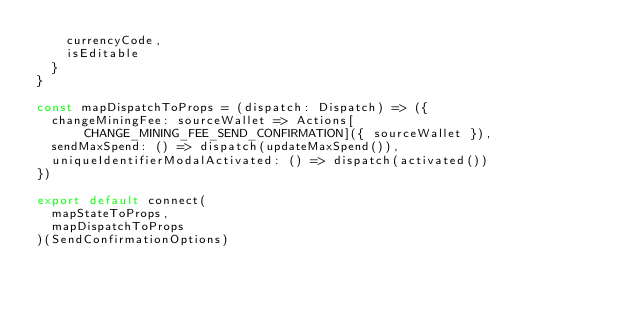Convert code to text. <code><loc_0><loc_0><loc_500><loc_500><_JavaScript_>    currencyCode,
    isEditable
  }
}

const mapDispatchToProps = (dispatch: Dispatch) => ({
  changeMiningFee: sourceWallet => Actions[CHANGE_MINING_FEE_SEND_CONFIRMATION]({ sourceWallet }),
  sendMaxSpend: () => dispatch(updateMaxSpend()),
  uniqueIdentifierModalActivated: () => dispatch(activated())
})

export default connect(
  mapStateToProps,
  mapDispatchToProps
)(SendConfirmationOptions)
</code> 